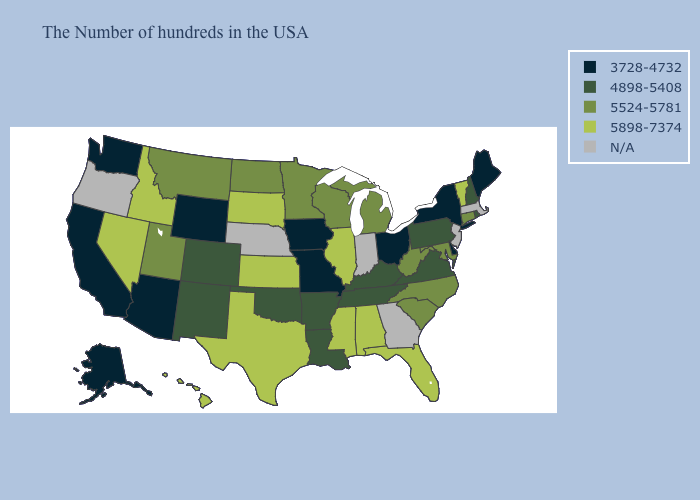What is the highest value in the USA?
Short answer required. 5898-7374. What is the lowest value in states that border Michigan?
Quick response, please. 3728-4732. What is the lowest value in states that border New Jersey?
Short answer required. 3728-4732. Does Vermont have the highest value in the Northeast?
Answer briefly. Yes. Which states have the lowest value in the USA?
Write a very short answer. Maine, New York, Delaware, Ohio, Missouri, Iowa, Wyoming, Arizona, California, Washington, Alaska. Does Wisconsin have the highest value in the USA?
Short answer required. No. What is the value of Idaho?
Concise answer only. 5898-7374. Name the states that have a value in the range N/A?
Keep it brief. Massachusetts, New Jersey, Georgia, Indiana, Nebraska, Oregon. What is the value of Idaho?
Write a very short answer. 5898-7374. Among the states that border Oklahoma , which have the highest value?
Short answer required. Kansas, Texas. Name the states that have a value in the range 3728-4732?
Concise answer only. Maine, New York, Delaware, Ohio, Missouri, Iowa, Wyoming, Arizona, California, Washington, Alaska. Does the map have missing data?
Quick response, please. Yes. What is the value of Alabama?
Quick response, please. 5898-7374. 